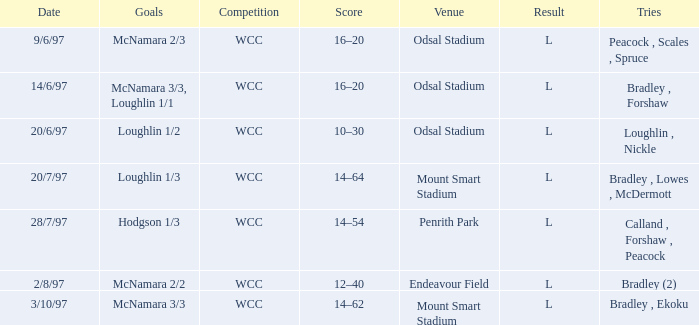What were the goals on 3/10/97? McNamara 3/3. 